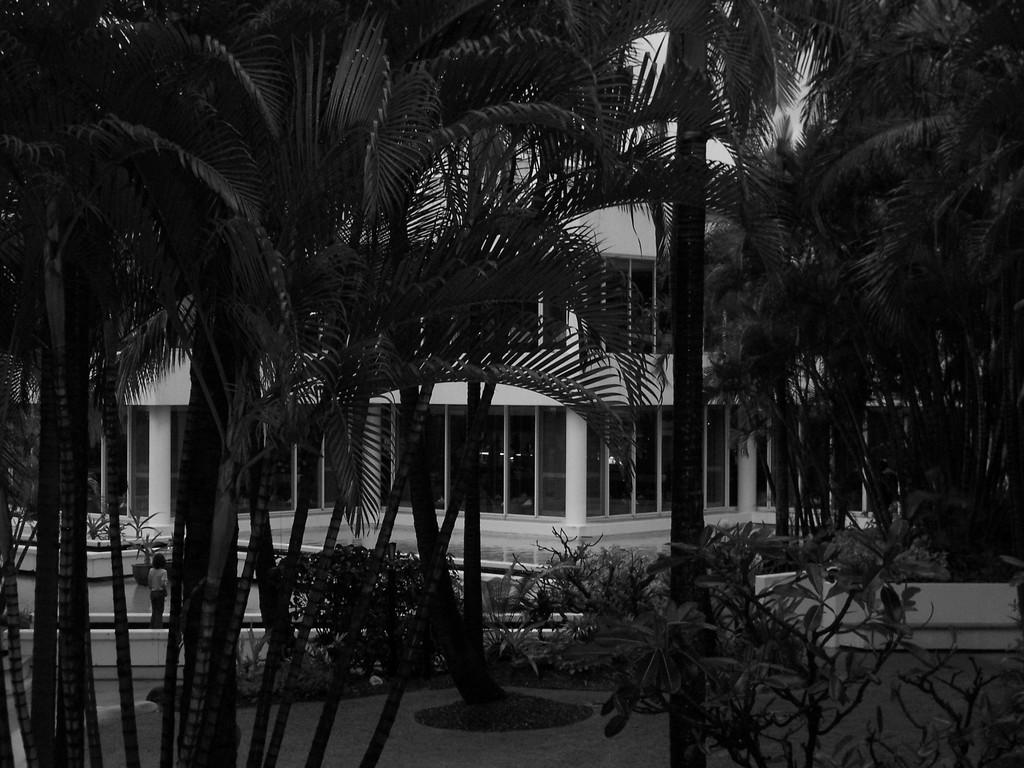What is the color scheme of the image? The image is black and white. What type of natural elements can be seen in the image? There are many trees and plants in the image. What type of man-made structure is visible in the background? There is a building in the background of the image. Can you describe the person in the image? There is a person on the left side of the image. What type of payment is being made in the image? There is no indication of any payment being made in the image. What type of power is being generated in the image? There is no power generation depicted in the image. 